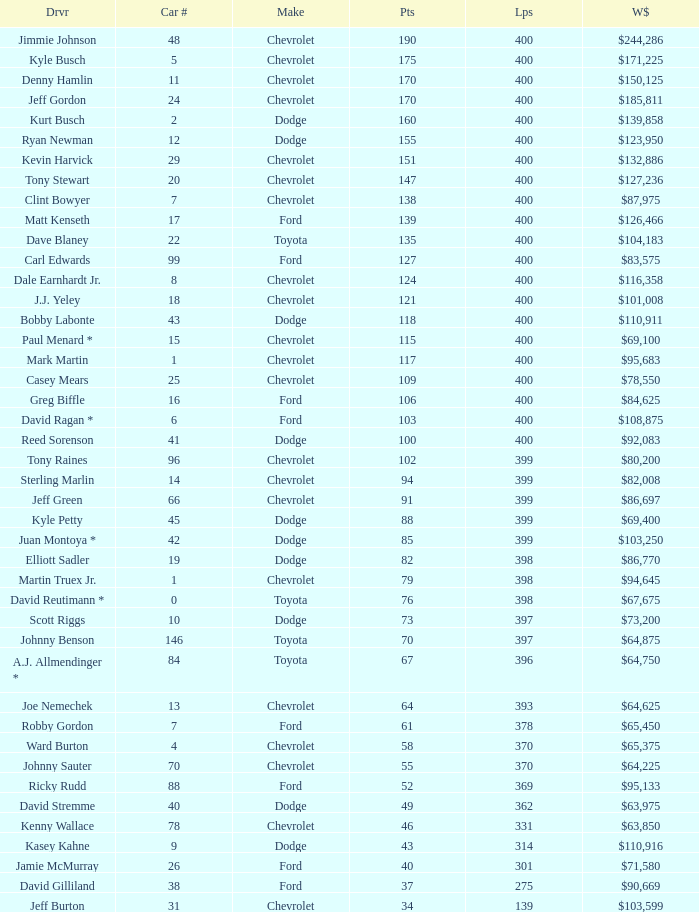What is the make of car 31? Chevrolet. 